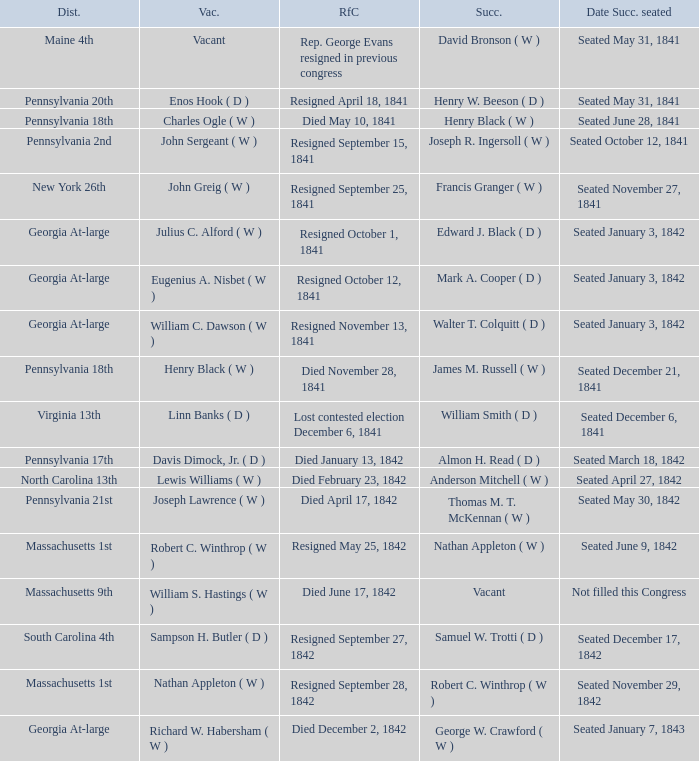Name the date successor seated for pennsylvania 17th Seated March 18, 1842. 